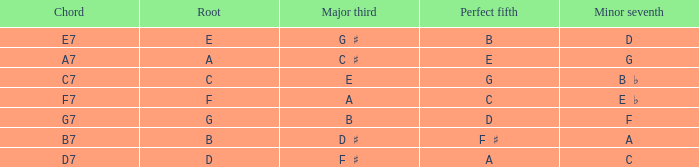What is the Perfect fifth with a Minor that is seventh of d? B. 